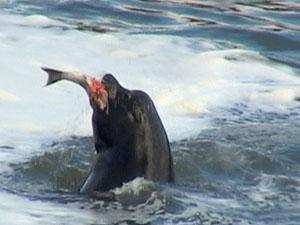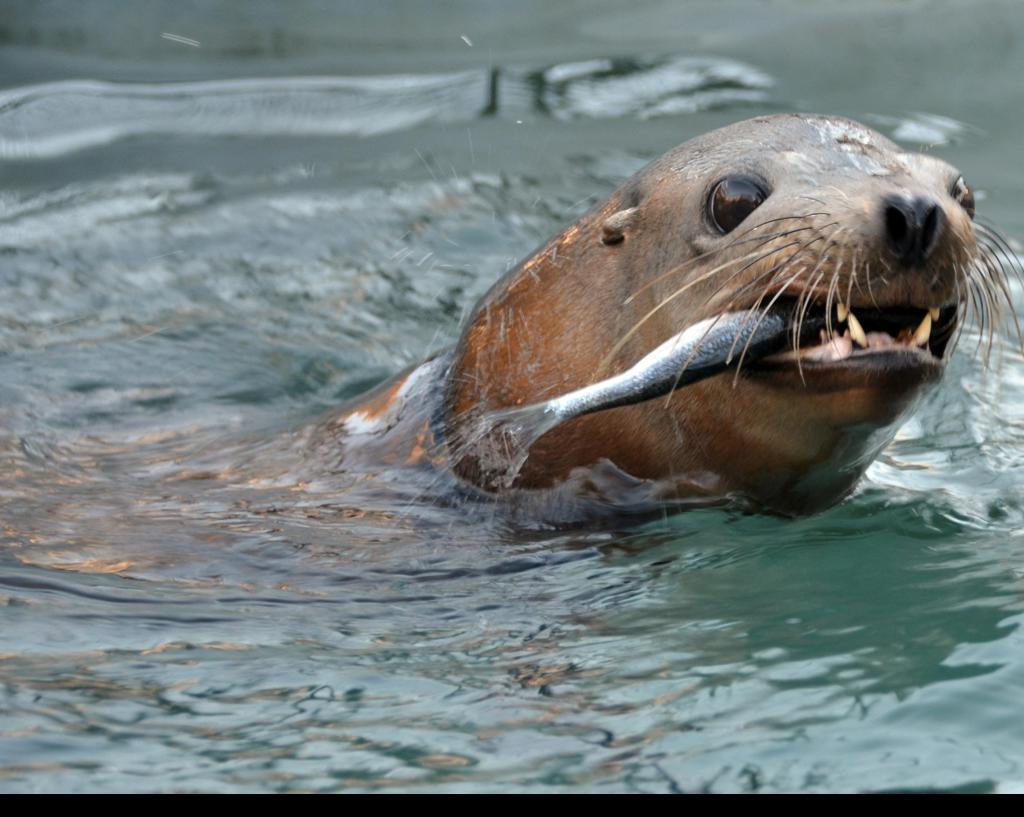The first image is the image on the left, the second image is the image on the right. Evaluate the accuracy of this statement regarding the images: "There is a seal in the water while feeding on a fish in the center of both images". Is it true? Answer yes or no. Yes. The first image is the image on the left, the second image is the image on the right. For the images shown, is this caption "Each image shows one seal with its head out of water and a fish caught in its mouth, and the seals in the left and right images face the same direction." true? Answer yes or no. No. 